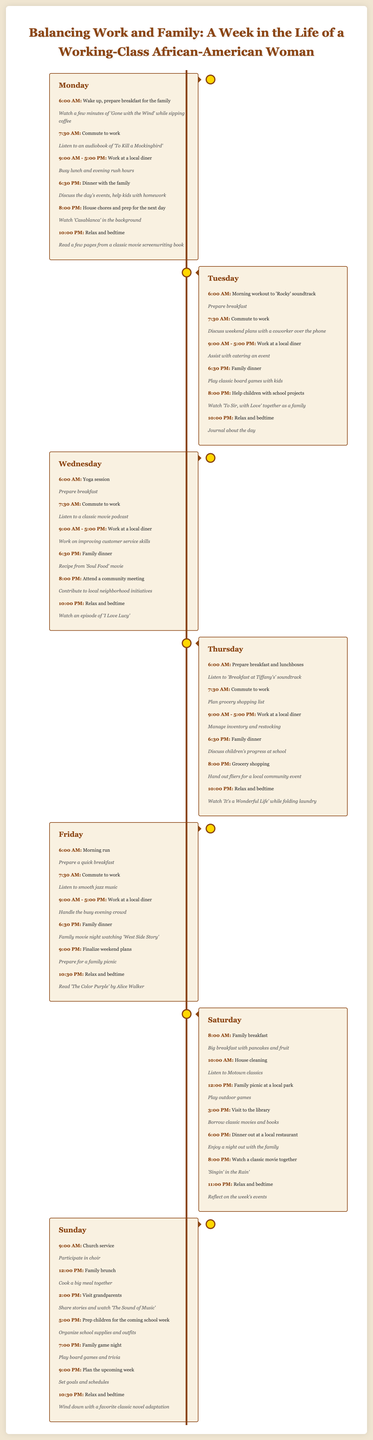what time does the family breakfast happen on Saturday? The family breakfast on Saturday is scheduled for 8:00 AM.
Answer: 8:00 AM how long is the woman’s work shift on Wednesday? The work shift on Wednesday lasts from 9:00 AM to 5:00 PM, which is 8 hours.
Answer: 8 hours what classic movie does she watch while folding laundry on Thursday? On Thursday, she watches "It's a Wonderful Life" while folding laundry.
Answer: It's a Wonderful Life on which day does she attend a community meeting? The community meeting is attended on Wednesday.
Answer: Wednesday what activity is scheduled for 7:00 PM on Sunday? At 7:00 PM on Sunday, the activity planned is family game night.
Answer: family game night what is the main meal she prepares on Sunday afternoon? On Sunday afternoon, she prepares a family brunch.
Answer: family brunch how does she relax after work on Monday? After work on Monday, she relaxes by watching "Casablanca" in the background.
Answer: "Casablanca" what soundtrack does she listen to during her morning workout on Tuesday? During her morning workout on Tuesday, she listens to the "Rocky" soundtrack.
Answer: Rocky what activity does she do after dinner on Friday? After dinner on Friday, she finalizes weekend plans.
Answer: finalize weekend plans 